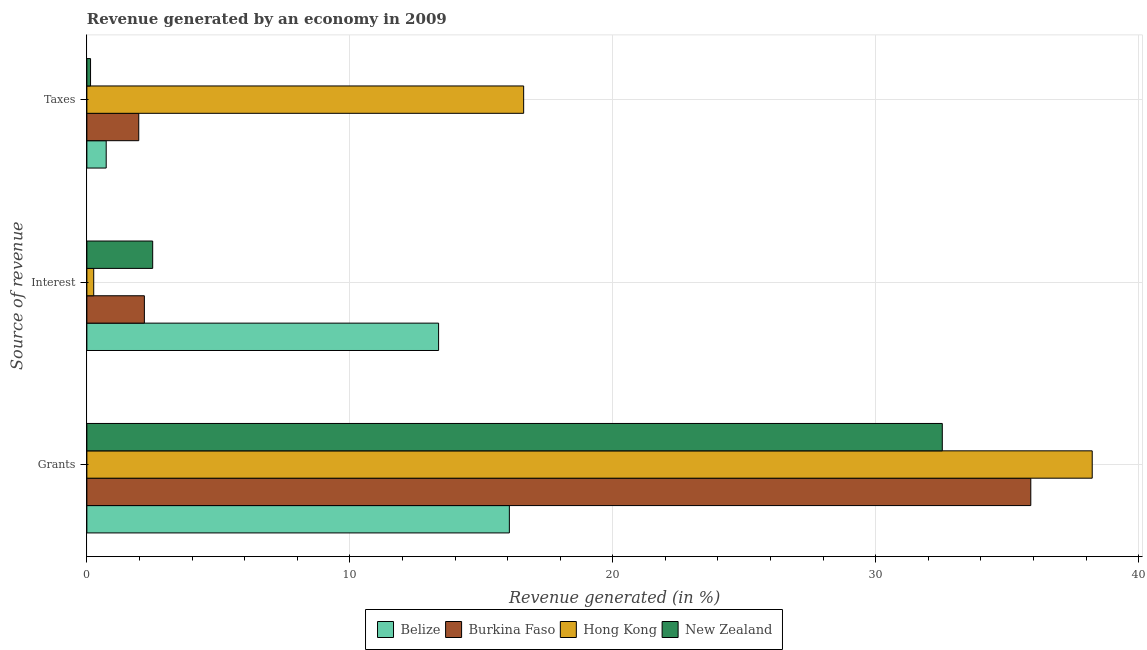What is the label of the 3rd group of bars from the top?
Keep it short and to the point. Grants. What is the percentage of revenue generated by interest in Burkina Faso?
Offer a terse response. 2.19. Across all countries, what is the maximum percentage of revenue generated by interest?
Your answer should be very brief. 13.37. Across all countries, what is the minimum percentage of revenue generated by taxes?
Your answer should be compact. 0.14. In which country was the percentage of revenue generated by grants maximum?
Offer a very short reply. Hong Kong. In which country was the percentage of revenue generated by taxes minimum?
Provide a short and direct response. New Zealand. What is the total percentage of revenue generated by interest in the graph?
Provide a succinct answer. 18.32. What is the difference between the percentage of revenue generated by interest in Belize and that in New Zealand?
Your response must be concise. 10.87. What is the difference between the percentage of revenue generated by grants in Hong Kong and the percentage of revenue generated by taxes in New Zealand?
Your answer should be very brief. 38.09. What is the average percentage of revenue generated by grants per country?
Your answer should be very brief. 30.68. What is the difference between the percentage of revenue generated by interest and percentage of revenue generated by taxes in New Zealand?
Ensure brevity in your answer.  2.36. What is the ratio of the percentage of revenue generated by interest in Hong Kong to that in New Zealand?
Your answer should be compact. 0.1. Is the percentage of revenue generated by taxes in Belize less than that in Hong Kong?
Your answer should be very brief. Yes. Is the difference between the percentage of revenue generated by interest in Burkina Faso and Hong Kong greater than the difference between the percentage of revenue generated by grants in Burkina Faso and Hong Kong?
Offer a very short reply. Yes. What is the difference between the highest and the second highest percentage of revenue generated by grants?
Provide a succinct answer. 2.34. What is the difference between the highest and the lowest percentage of revenue generated by interest?
Provide a succinct answer. 13.11. In how many countries, is the percentage of revenue generated by taxes greater than the average percentage of revenue generated by taxes taken over all countries?
Offer a very short reply. 1. What does the 1st bar from the top in Grants represents?
Make the answer very short. New Zealand. What does the 2nd bar from the bottom in Taxes represents?
Ensure brevity in your answer.  Burkina Faso. Are all the bars in the graph horizontal?
Keep it short and to the point. Yes. Are the values on the major ticks of X-axis written in scientific E-notation?
Keep it short and to the point. No. Does the graph contain grids?
Your answer should be very brief. Yes. Where does the legend appear in the graph?
Keep it short and to the point. Bottom center. How are the legend labels stacked?
Ensure brevity in your answer.  Horizontal. What is the title of the graph?
Ensure brevity in your answer.  Revenue generated by an economy in 2009. Does "Middle income" appear as one of the legend labels in the graph?
Give a very brief answer. No. What is the label or title of the X-axis?
Ensure brevity in your answer.  Revenue generated (in %). What is the label or title of the Y-axis?
Make the answer very short. Source of revenue. What is the Revenue generated (in %) of Belize in Grants?
Your answer should be very brief. 16.07. What is the Revenue generated (in %) in Burkina Faso in Grants?
Offer a very short reply. 35.9. What is the Revenue generated (in %) in Hong Kong in Grants?
Offer a terse response. 38.23. What is the Revenue generated (in %) of New Zealand in Grants?
Provide a short and direct response. 32.53. What is the Revenue generated (in %) of Belize in Interest?
Provide a succinct answer. 13.37. What is the Revenue generated (in %) of Burkina Faso in Interest?
Provide a short and direct response. 2.19. What is the Revenue generated (in %) in Hong Kong in Interest?
Offer a very short reply. 0.26. What is the Revenue generated (in %) in New Zealand in Interest?
Offer a terse response. 2.5. What is the Revenue generated (in %) of Belize in Taxes?
Your response must be concise. 0.73. What is the Revenue generated (in %) in Burkina Faso in Taxes?
Give a very brief answer. 1.97. What is the Revenue generated (in %) in Hong Kong in Taxes?
Offer a very short reply. 16.61. What is the Revenue generated (in %) of New Zealand in Taxes?
Your answer should be compact. 0.14. Across all Source of revenue, what is the maximum Revenue generated (in %) of Belize?
Give a very brief answer. 16.07. Across all Source of revenue, what is the maximum Revenue generated (in %) in Burkina Faso?
Provide a succinct answer. 35.9. Across all Source of revenue, what is the maximum Revenue generated (in %) in Hong Kong?
Your answer should be very brief. 38.23. Across all Source of revenue, what is the maximum Revenue generated (in %) of New Zealand?
Provide a short and direct response. 32.53. Across all Source of revenue, what is the minimum Revenue generated (in %) of Belize?
Your response must be concise. 0.73. Across all Source of revenue, what is the minimum Revenue generated (in %) of Burkina Faso?
Your answer should be compact. 1.97. Across all Source of revenue, what is the minimum Revenue generated (in %) of Hong Kong?
Offer a terse response. 0.26. Across all Source of revenue, what is the minimum Revenue generated (in %) in New Zealand?
Your answer should be very brief. 0.14. What is the total Revenue generated (in %) of Belize in the graph?
Offer a terse response. 30.18. What is the total Revenue generated (in %) of Burkina Faso in the graph?
Keep it short and to the point. 40.05. What is the total Revenue generated (in %) of Hong Kong in the graph?
Make the answer very short. 55.1. What is the total Revenue generated (in %) of New Zealand in the graph?
Your answer should be very brief. 35.17. What is the difference between the Revenue generated (in %) in Belize in Grants and that in Interest?
Offer a very short reply. 2.69. What is the difference between the Revenue generated (in %) in Burkina Faso in Grants and that in Interest?
Ensure brevity in your answer.  33.71. What is the difference between the Revenue generated (in %) in Hong Kong in Grants and that in Interest?
Provide a short and direct response. 37.97. What is the difference between the Revenue generated (in %) in New Zealand in Grants and that in Interest?
Make the answer very short. 30.03. What is the difference between the Revenue generated (in %) of Belize in Grants and that in Taxes?
Offer a very short reply. 15.33. What is the difference between the Revenue generated (in %) in Burkina Faso in Grants and that in Taxes?
Make the answer very short. 33.92. What is the difference between the Revenue generated (in %) of Hong Kong in Grants and that in Taxes?
Ensure brevity in your answer.  21.62. What is the difference between the Revenue generated (in %) of New Zealand in Grants and that in Taxes?
Keep it short and to the point. 32.39. What is the difference between the Revenue generated (in %) in Belize in Interest and that in Taxes?
Keep it short and to the point. 12.64. What is the difference between the Revenue generated (in %) of Burkina Faso in Interest and that in Taxes?
Give a very brief answer. 0.21. What is the difference between the Revenue generated (in %) in Hong Kong in Interest and that in Taxes?
Ensure brevity in your answer.  -16.35. What is the difference between the Revenue generated (in %) in New Zealand in Interest and that in Taxes?
Your answer should be very brief. 2.36. What is the difference between the Revenue generated (in %) in Belize in Grants and the Revenue generated (in %) in Burkina Faso in Interest?
Make the answer very short. 13.88. What is the difference between the Revenue generated (in %) in Belize in Grants and the Revenue generated (in %) in Hong Kong in Interest?
Offer a very short reply. 15.81. What is the difference between the Revenue generated (in %) of Belize in Grants and the Revenue generated (in %) of New Zealand in Interest?
Keep it short and to the point. 13.56. What is the difference between the Revenue generated (in %) of Burkina Faso in Grants and the Revenue generated (in %) of Hong Kong in Interest?
Your answer should be compact. 35.64. What is the difference between the Revenue generated (in %) in Burkina Faso in Grants and the Revenue generated (in %) in New Zealand in Interest?
Offer a very short reply. 33.39. What is the difference between the Revenue generated (in %) in Hong Kong in Grants and the Revenue generated (in %) in New Zealand in Interest?
Offer a very short reply. 35.73. What is the difference between the Revenue generated (in %) in Belize in Grants and the Revenue generated (in %) in Burkina Faso in Taxes?
Your answer should be compact. 14.09. What is the difference between the Revenue generated (in %) in Belize in Grants and the Revenue generated (in %) in Hong Kong in Taxes?
Keep it short and to the point. -0.54. What is the difference between the Revenue generated (in %) of Belize in Grants and the Revenue generated (in %) of New Zealand in Taxes?
Offer a very short reply. 15.93. What is the difference between the Revenue generated (in %) of Burkina Faso in Grants and the Revenue generated (in %) of Hong Kong in Taxes?
Your answer should be very brief. 19.29. What is the difference between the Revenue generated (in %) in Burkina Faso in Grants and the Revenue generated (in %) in New Zealand in Taxes?
Your answer should be very brief. 35.76. What is the difference between the Revenue generated (in %) in Hong Kong in Grants and the Revenue generated (in %) in New Zealand in Taxes?
Your answer should be compact. 38.09. What is the difference between the Revenue generated (in %) of Belize in Interest and the Revenue generated (in %) of Burkina Faso in Taxes?
Give a very brief answer. 11.4. What is the difference between the Revenue generated (in %) in Belize in Interest and the Revenue generated (in %) in Hong Kong in Taxes?
Provide a succinct answer. -3.23. What is the difference between the Revenue generated (in %) in Belize in Interest and the Revenue generated (in %) in New Zealand in Taxes?
Make the answer very short. 13.24. What is the difference between the Revenue generated (in %) in Burkina Faso in Interest and the Revenue generated (in %) in Hong Kong in Taxes?
Your answer should be compact. -14.42. What is the difference between the Revenue generated (in %) of Burkina Faso in Interest and the Revenue generated (in %) of New Zealand in Taxes?
Your answer should be compact. 2.05. What is the difference between the Revenue generated (in %) of Hong Kong in Interest and the Revenue generated (in %) of New Zealand in Taxes?
Your response must be concise. 0.12. What is the average Revenue generated (in %) in Belize per Source of revenue?
Your answer should be very brief. 10.06. What is the average Revenue generated (in %) in Burkina Faso per Source of revenue?
Provide a short and direct response. 13.35. What is the average Revenue generated (in %) in Hong Kong per Source of revenue?
Your response must be concise. 18.37. What is the average Revenue generated (in %) of New Zealand per Source of revenue?
Make the answer very short. 11.72. What is the difference between the Revenue generated (in %) of Belize and Revenue generated (in %) of Burkina Faso in Grants?
Your response must be concise. -19.83. What is the difference between the Revenue generated (in %) of Belize and Revenue generated (in %) of Hong Kong in Grants?
Your answer should be very brief. -22.17. What is the difference between the Revenue generated (in %) in Belize and Revenue generated (in %) in New Zealand in Grants?
Offer a terse response. -16.46. What is the difference between the Revenue generated (in %) of Burkina Faso and Revenue generated (in %) of Hong Kong in Grants?
Offer a very short reply. -2.34. What is the difference between the Revenue generated (in %) in Burkina Faso and Revenue generated (in %) in New Zealand in Grants?
Offer a terse response. 3.37. What is the difference between the Revenue generated (in %) of Hong Kong and Revenue generated (in %) of New Zealand in Grants?
Give a very brief answer. 5.7. What is the difference between the Revenue generated (in %) in Belize and Revenue generated (in %) in Burkina Faso in Interest?
Give a very brief answer. 11.19. What is the difference between the Revenue generated (in %) of Belize and Revenue generated (in %) of Hong Kong in Interest?
Your answer should be very brief. 13.11. What is the difference between the Revenue generated (in %) in Belize and Revenue generated (in %) in New Zealand in Interest?
Ensure brevity in your answer.  10.87. What is the difference between the Revenue generated (in %) of Burkina Faso and Revenue generated (in %) of Hong Kong in Interest?
Make the answer very short. 1.93. What is the difference between the Revenue generated (in %) in Burkina Faso and Revenue generated (in %) in New Zealand in Interest?
Your response must be concise. -0.32. What is the difference between the Revenue generated (in %) in Hong Kong and Revenue generated (in %) in New Zealand in Interest?
Your answer should be very brief. -2.24. What is the difference between the Revenue generated (in %) in Belize and Revenue generated (in %) in Burkina Faso in Taxes?
Your answer should be compact. -1.24. What is the difference between the Revenue generated (in %) of Belize and Revenue generated (in %) of Hong Kong in Taxes?
Make the answer very short. -15.88. What is the difference between the Revenue generated (in %) in Belize and Revenue generated (in %) in New Zealand in Taxes?
Provide a succinct answer. 0.6. What is the difference between the Revenue generated (in %) of Burkina Faso and Revenue generated (in %) of Hong Kong in Taxes?
Offer a terse response. -14.64. What is the difference between the Revenue generated (in %) in Burkina Faso and Revenue generated (in %) in New Zealand in Taxes?
Offer a very short reply. 1.83. What is the difference between the Revenue generated (in %) of Hong Kong and Revenue generated (in %) of New Zealand in Taxes?
Give a very brief answer. 16.47. What is the ratio of the Revenue generated (in %) of Belize in Grants to that in Interest?
Your answer should be very brief. 1.2. What is the ratio of the Revenue generated (in %) of Burkina Faso in Grants to that in Interest?
Provide a succinct answer. 16.42. What is the ratio of the Revenue generated (in %) in Hong Kong in Grants to that in Interest?
Offer a very short reply. 146.89. What is the ratio of the Revenue generated (in %) in New Zealand in Grants to that in Interest?
Keep it short and to the point. 13. What is the ratio of the Revenue generated (in %) in Belize in Grants to that in Taxes?
Offer a terse response. 21.87. What is the ratio of the Revenue generated (in %) in Burkina Faso in Grants to that in Taxes?
Give a very brief answer. 18.2. What is the ratio of the Revenue generated (in %) in Hong Kong in Grants to that in Taxes?
Make the answer very short. 2.3. What is the ratio of the Revenue generated (in %) of New Zealand in Grants to that in Taxes?
Offer a terse response. 233.51. What is the ratio of the Revenue generated (in %) of Belize in Interest to that in Taxes?
Offer a terse response. 18.2. What is the ratio of the Revenue generated (in %) of Burkina Faso in Interest to that in Taxes?
Provide a succinct answer. 1.11. What is the ratio of the Revenue generated (in %) in Hong Kong in Interest to that in Taxes?
Offer a terse response. 0.02. What is the ratio of the Revenue generated (in %) in New Zealand in Interest to that in Taxes?
Provide a short and direct response. 17.96. What is the difference between the highest and the second highest Revenue generated (in %) in Belize?
Provide a succinct answer. 2.69. What is the difference between the highest and the second highest Revenue generated (in %) in Burkina Faso?
Offer a very short reply. 33.71. What is the difference between the highest and the second highest Revenue generated (in %) of Hong Kong?
Provide a succinct answer. 21.62. What is the difference between the highest and the second highest Revenue generated (in %) of New Zealand?
Ensure brevity in your answer.  30.03. What is the difference between the highest and the lowest Revenue generated (in %) of Belize?
Your answer should be very brief. 15.33. What is the difference between the highest and the lowest Revenue generated (in %) in Burkina Faso?
Keep it short and to the point. 33.92. What is the difference between the highest and the lowest Revenue generated (in %) of Hong Kong?
Offer a terse response. 37.97. What is the difference between the highest and the lowest Revenue generated (in %) of New Zealand?
Provide a short and direct response. 32.39. 